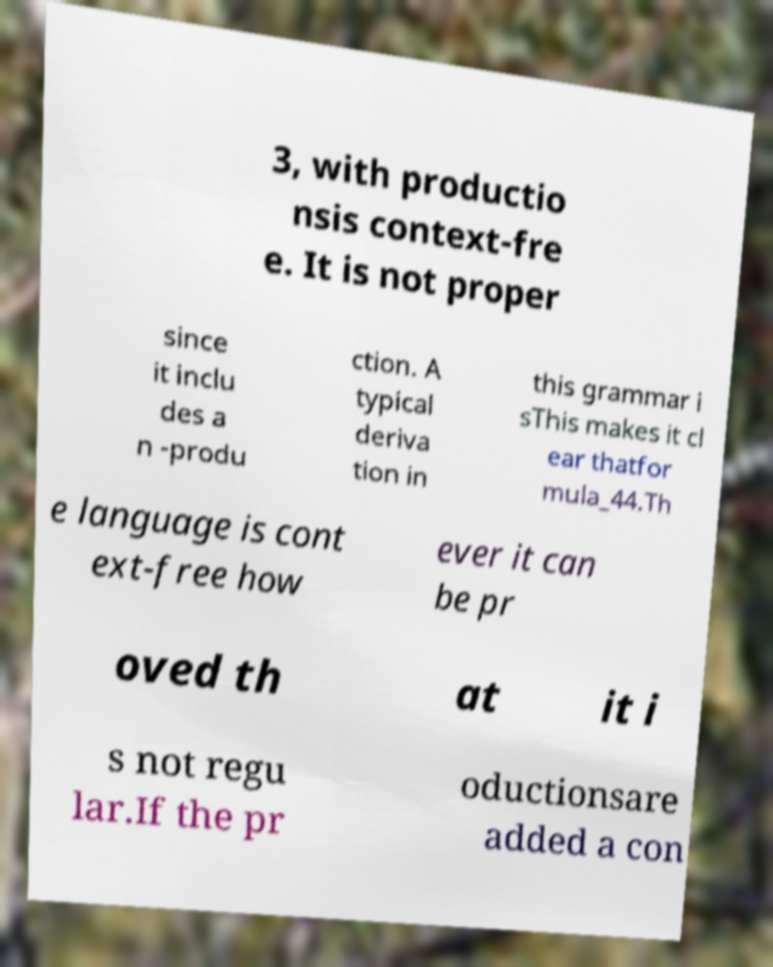What messages or text are displayed in this image? I need them in a readable, typed format. 3, with productio nsis context-fre e. It is not proper since it inclu des a n -produ ction. A typical deriva tion in this grammar i sThis makes it cl ear thatfor mula_44.Th e language is cont ext-free how ever it can be pr oved th at it i s not regu lar.If the pr oductionsare added a con 